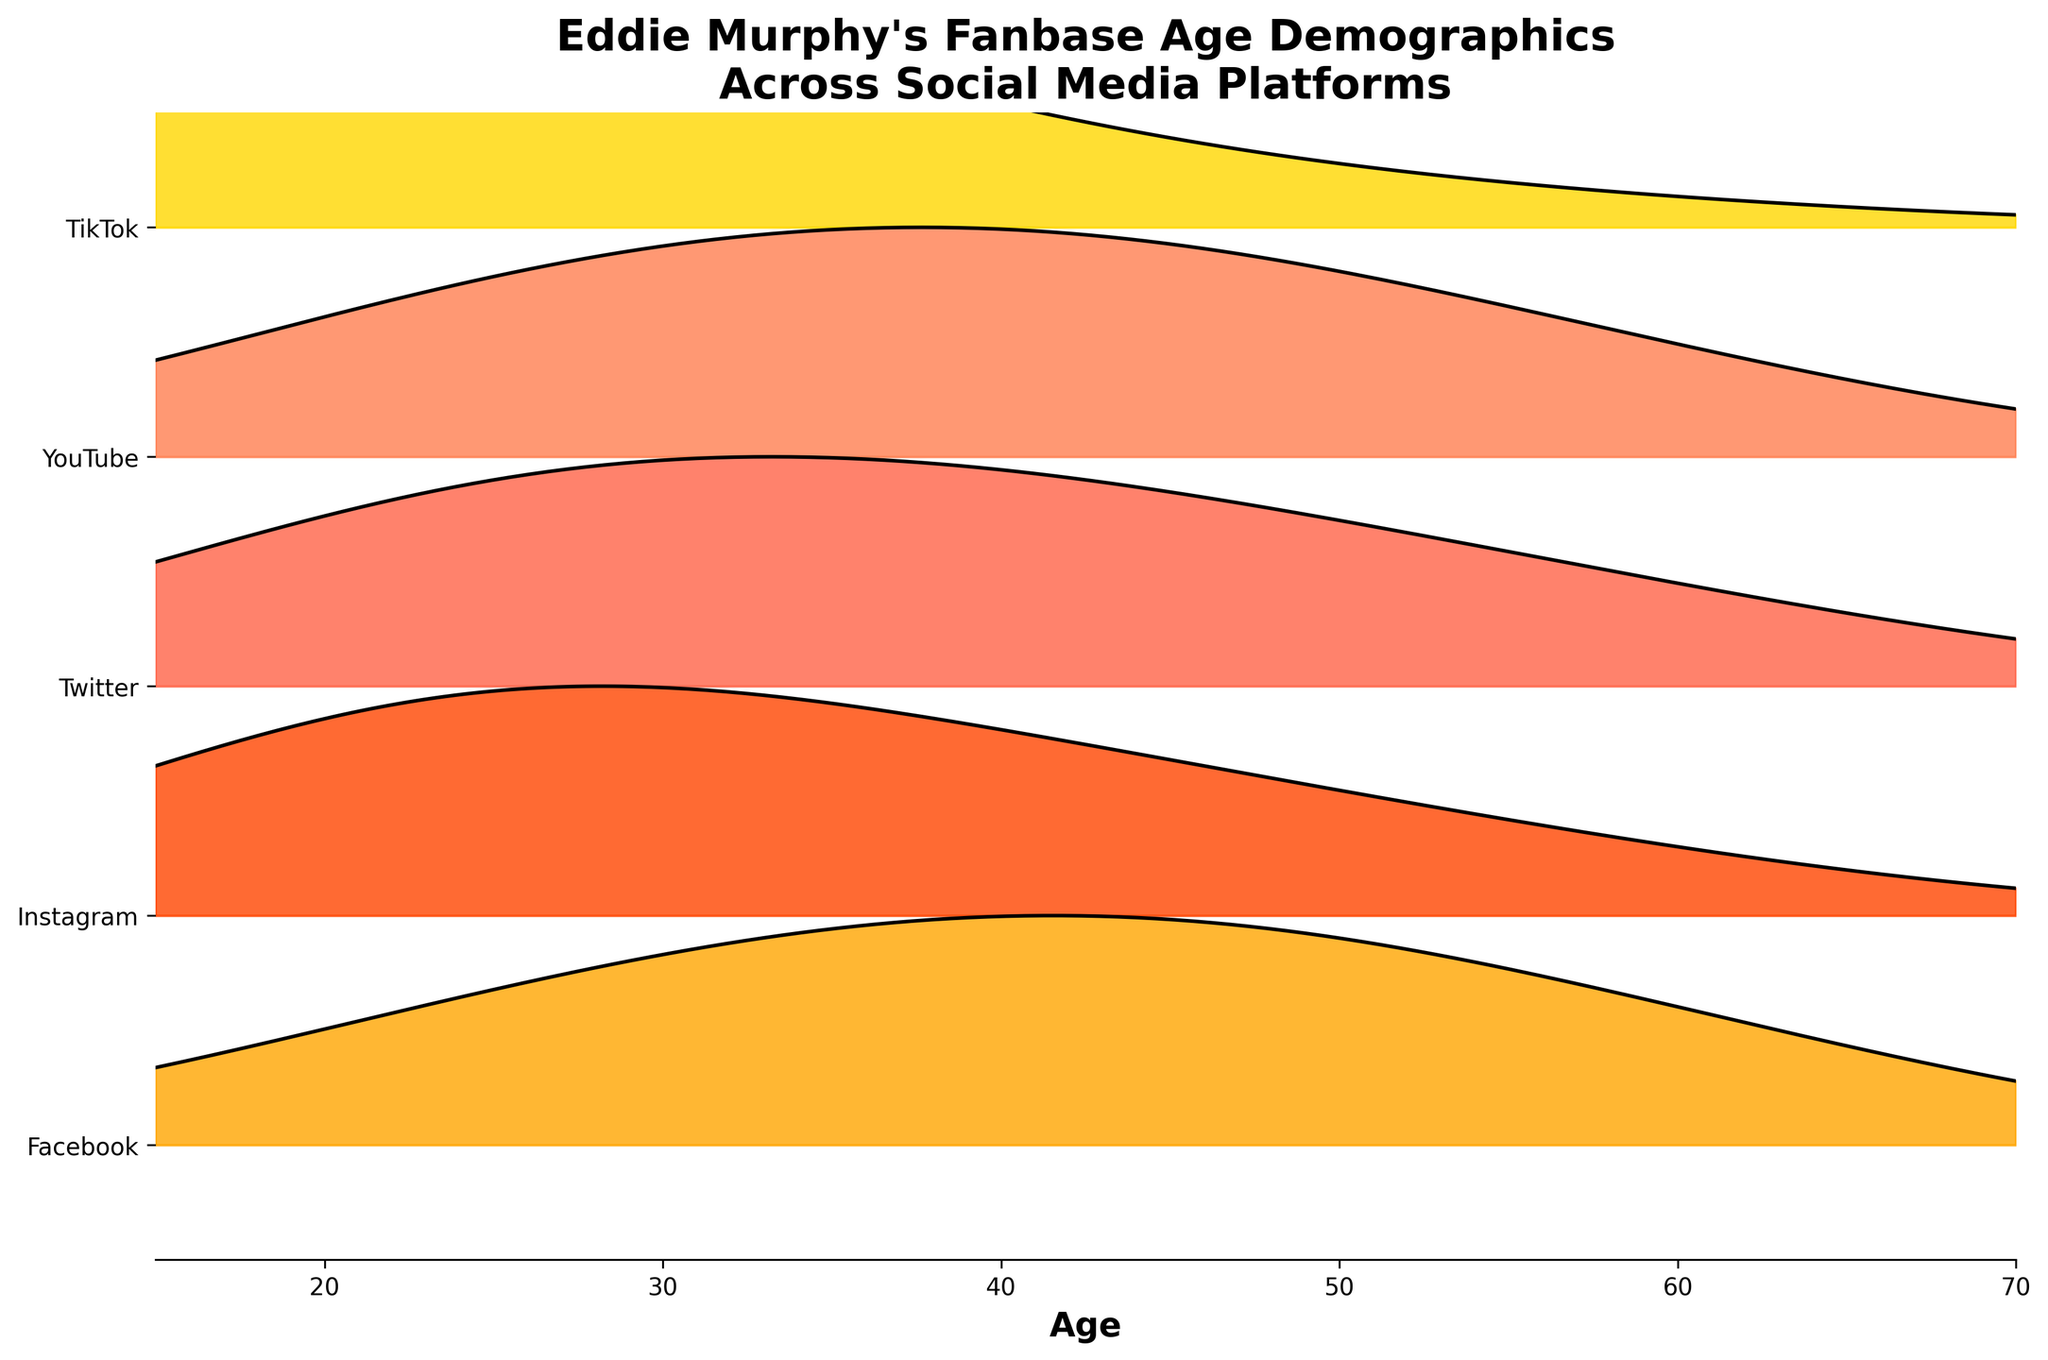What’s the title of the plot? The title is located at the top of the plot and specifies what the figure is about.
Answer: Eddie Murphy's Fanbase Age Demographics Across Social Media Platforms Which social media platform has the highest density of fans aged 18? Examine the height of the density curve for each platform at age 18.
Answer: TikTok What are the age ranges covered on the plot? Look at the x-axis to determine the range values.
Answer: 15 to 70 Which platform shows the widest age distribution? Assess which platform's ridgeline spans the greatest range of ages, indicated by the width of the curves.
Answer: Facebook Which social media platform has nearly the same density for ages 18 and 25? Compare the density values for ages 18 and 25 for each platform's curve.
Answer: Twitter Compare the density of fans aged 55 on YouTube and Instagram. Which is higher? Identify the density value at age 55 for YouTube and Instagram and compare them.
Answer: YouTube For TikTok, does the fan density increase or decrease with age? Observe the trend in the density values for TikTok as age increases from 18 to 65.
Answer: Decrease Which social media platform has the peak fan density at age 45? Locate the highest point on the plot for age 45 across all platforms.
Answer: Facebook How does the fan density for age 35 compare between YouTube and Facebook? Evaluate the density values for age 35 for both YouTube and Facebook and compare them.
Answer: YouTube is higher Is the fanbase for Instagram younger or older compared to Facebook? Compare the general density trends across age ranges for Instagram and Facebook.
Answer: Younger 